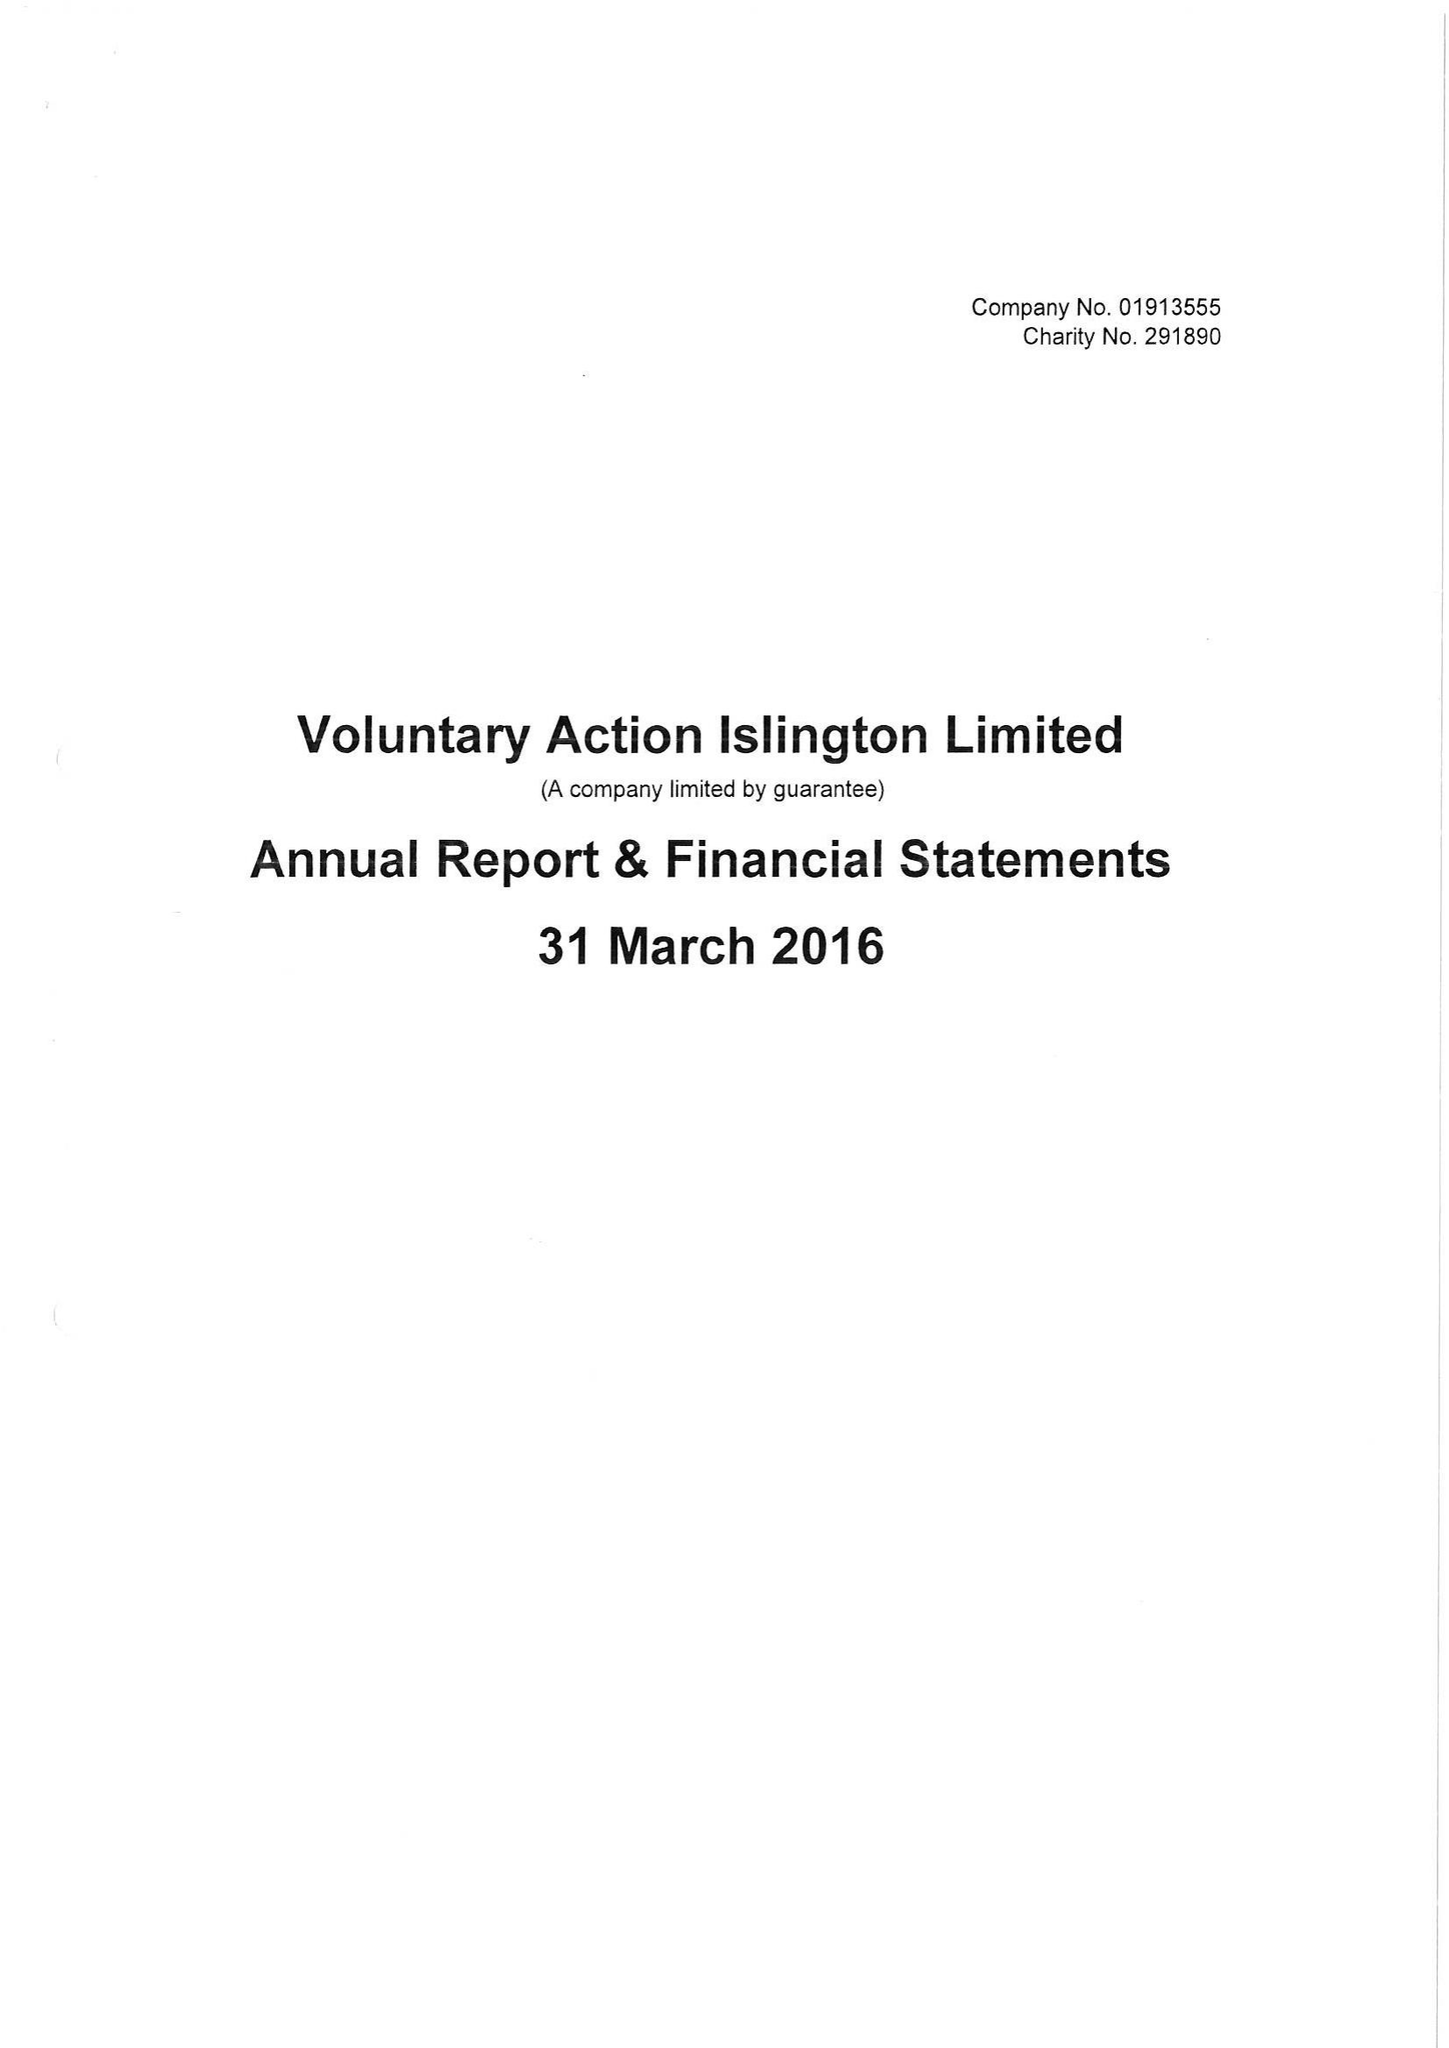What is the value for the charity_name?
Answer the question using a single word or phrase. Voluntary Action Islington Ltd. 